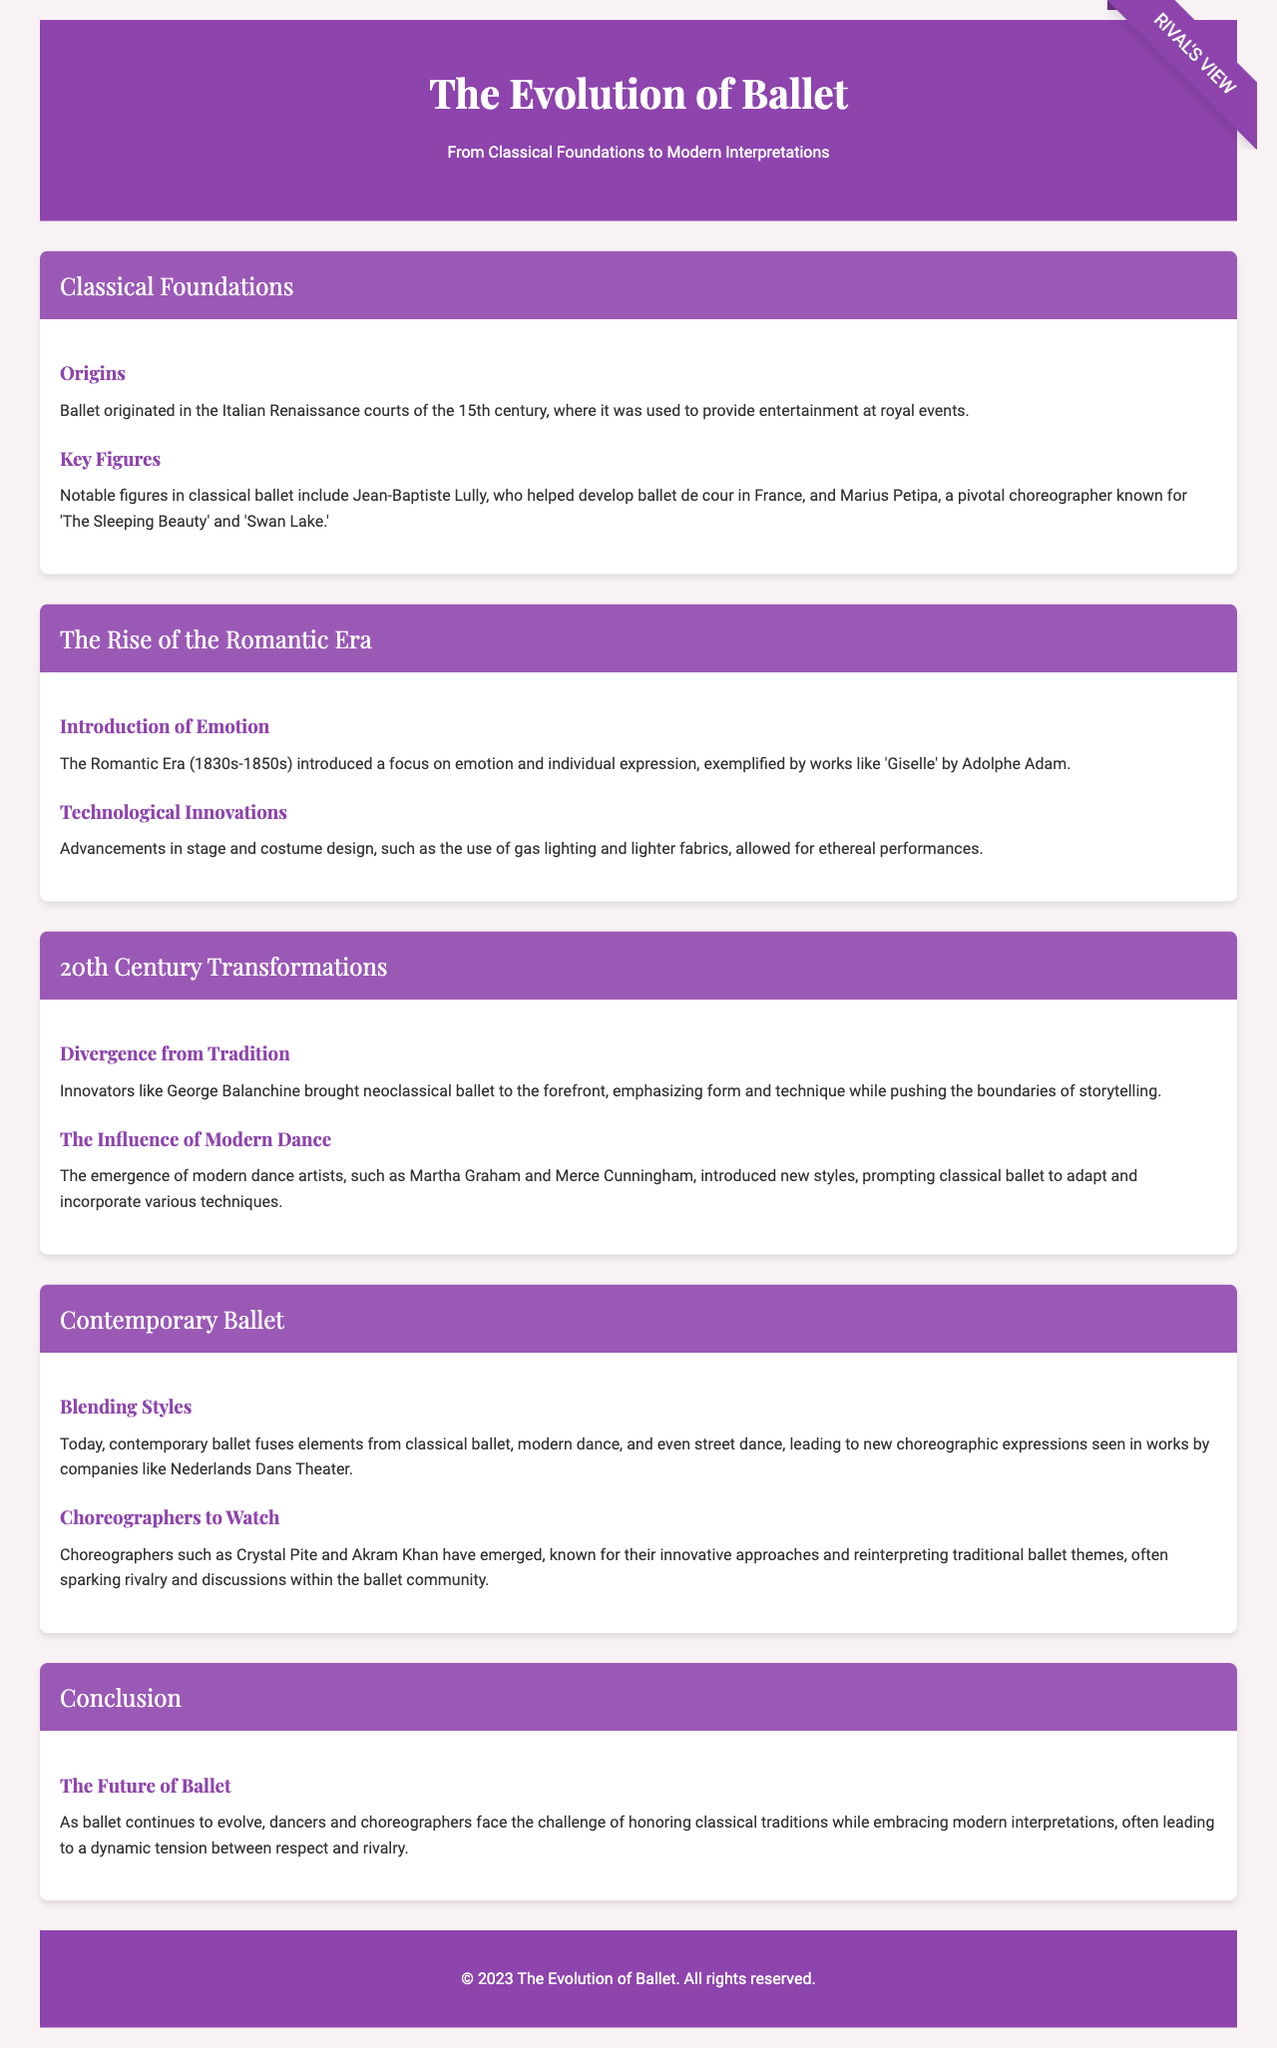what is the title of the brochure? The title of the brochure is stated at the top of the document.
Answer: The Evolution of Ballet who is a pivotal choreographer known for 'Swan Lake'? The document lists Marius Petipa as a pivotal choreographer associated with 'Swan Lake'.
Answer: Marius Petipa which era introduced a focus on emotion in ballet? The section mentions the Romantic Era as a time that emphasized emotion.
Answer: Romantic Era who were the innovators that brought neoclassical ballet to the forefront? The document identifies George Balanchine as an innovator in neoclassical ballet.
Answer: George Balanchine what are two modern dance artists mentioned? The document specifies Martha Graham and Merce Cunningham as modern dance artists.
Answer: Martha Graham, Merce Cunningham what is one contemporary ballet company noted for fusing styles? The document mentions Nederlands Dans Theater as a company blending ballet styles.
Answer: Nederlands Dans Theater which choreographers are highlighted for their innovative approaches? The brochure highlights Crystal Pite and Akram Khan for their approaches in contemporary ballet.
Answer: Crystal Pite, Akram Khan what is the main challenge faced by dancers and choreographers today? The conclusion summarizes the challenge as balancing classical traditions with modern interpretations.
Answer: Balancing classical traditions with modern interpretations 